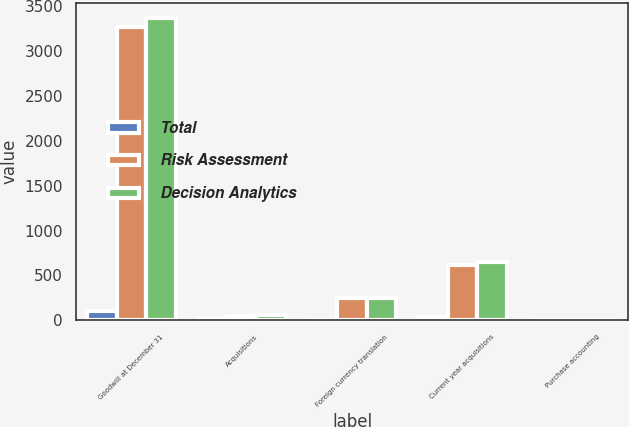<chart> <loc_0><loc_0><loc_500><loc_500><stacked_bar_chart><ecel><fcel>Goodwill at December 31<fcel>Acquisitions<fcel>Foreign currency translation<fcel>Current year acquisitions<fcel>Purchase accounting<nl><fcel>Total<fcel>104.5<fcel>16.2<fcel>0.4<fcel>32.7<fcel>2.8<nl><fcel>Risk Assessment<fcel>3264.2<fcel>43.8<fcel>247.3<fcel>613.8<fcel>1.6<nl><fcel>Decision Analytics<fcel>3368.7<fcel>60<fcel>247.7<fcel>646.5<fcel>4.4<nl></chart> 